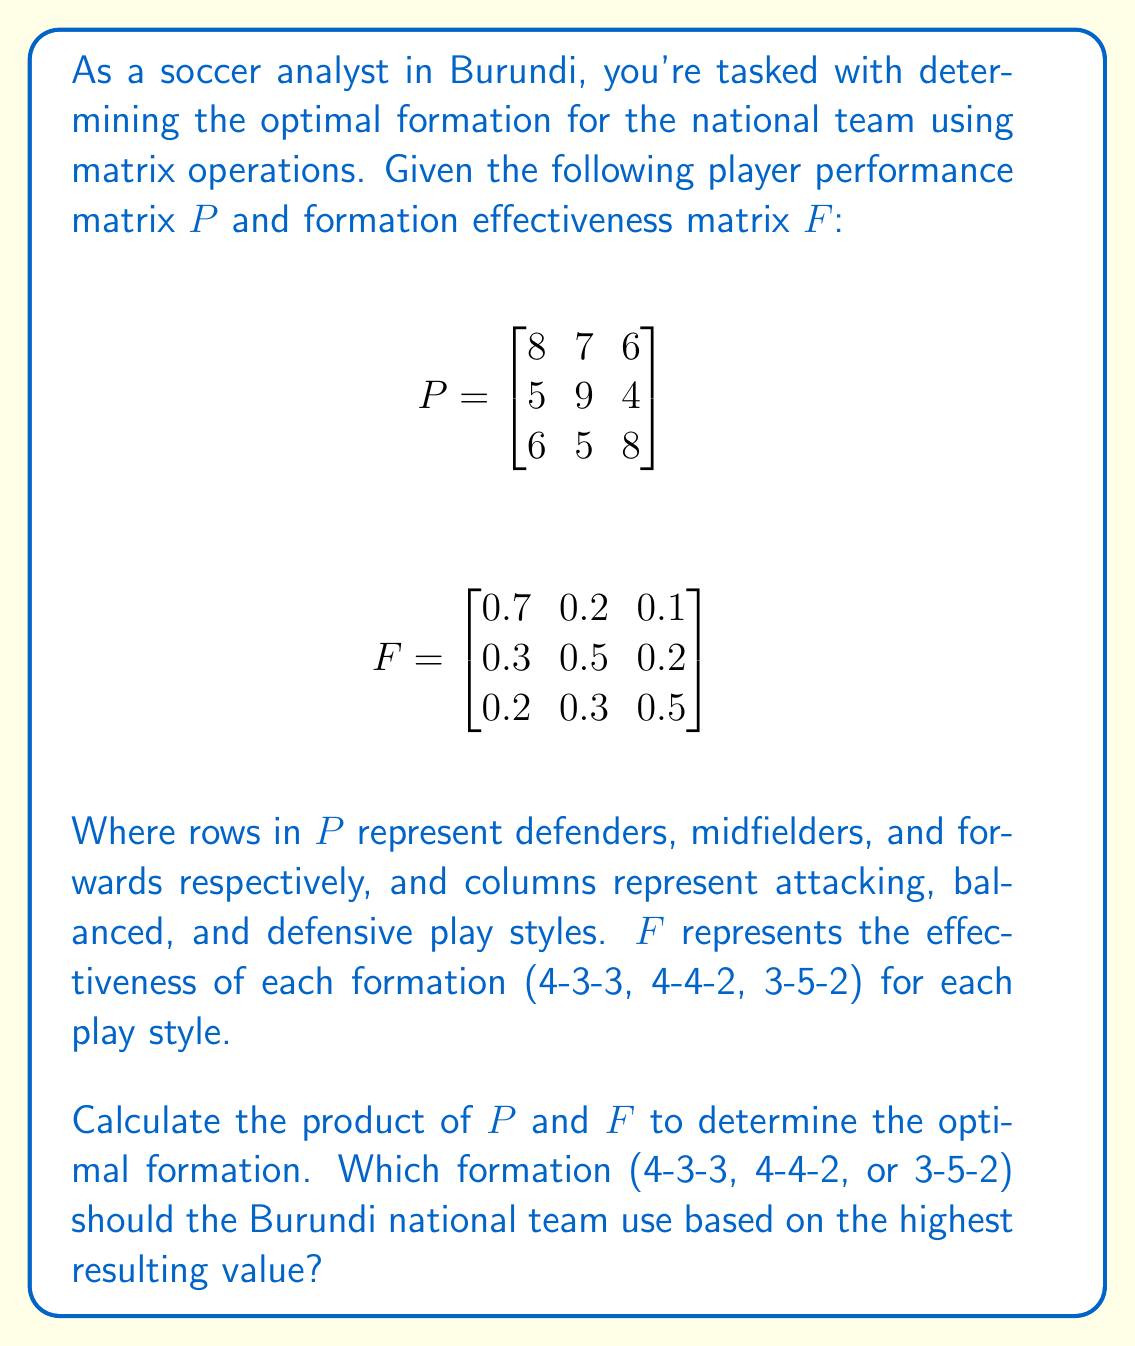What is the answer to this math problem? To solve this problem, we need to multiply the player performance matrix $P$ with the formation effectiveness matrix $F$. The resulting matrix will give us the overall effectiveness of each formation.

Step 1: Multiply $P$ and $F$

$$PF = \begin{bmatrix}
8 & 7 & 6 \\
5 & 9 & 4 \\
6 & 5 & 8
\end{bmatrix} \times 
\begin{bmatrix}
0.7 & 0.2 & 0.1 \\
0.3 & 0.5 & 0.2 \\
0.2 & 0.3 & 0.5
\end{bmatrix}$$

Step 2: Perform the matrix multiplication

$$(PF)_{11} = 8(0.7) + 7(0.3) + 6(0.2) = 5.6 + 2.1 + 1.2 = 8.9$$
$$(PF)_{12} = 8(0.2) + 7(0.5) + 6(0.3) = 1.6 + 3.5 + 1.8 = 6.9$$
$$(PF)_{13} = 8(0.1) + 7(0.2) + 6(0.5) = 0.8 + 1.4 + 3.0 = 5.2$$

$$(PF)_{21} = 5(0.7) + 9(0.3) + 4(0.2) = 3.5 + 2.7 + 0.8 = 7.0$$
$$(PF)_{22} = 5(0.2) + 9(0.5) + 4(0.3) = 1.0 + 4.5 + 1.2 = 6.7$$
$$(PF)_{23} = 5(0.1) + 9(0.2) + 4(0.5) = 0.5 + 1.8 + 2.0 = 4.3$$

$$(PF)_{31} = 6(0.7) + 5(0.3) + 8(0.2) = 4.2 + 1.5 + 1.6 = 7.3$$
$$(PF)_{32} = 6(0.2) + 5(0.5) + 8(0.3) = 1.2 + 2.5 + 2.4 = 6.1$$
$$(PF)_{33} = 6(0.1) + 5(0.2) + 8(0.5) = 0.6 + 1.0 + 4.0 = 5.6$$

The resulting matrix is:

$$PF = \begin{bmatrix}
8.9 & 6.9 & 5.2 \\
7.0 & 6.7 & 4.3 \\
7.3 & 6.1 & 5.6
\end{bmatrix}$$

Step 3: Interpret the results

The columns of the resulting matrix represent the effectiveness of each formation:
1. First column (8.9, 7.0, 7.3) represents 4-3-3 formation
2. Second column (6.9, 6.7, 6.1) represents 4-4-2 formation
3. Third column (5.2, 4.3, 5.6) represents 3-5-2 formation

The highest value in the matrix is 8.9, which corresponds to the 4-3-3 formation.
Answer: The Burundi national team should use the 4-3-3 formation, as it has the highest effectiveness value of 8.9 based on the given player performance and formation effectiveness matrices. 